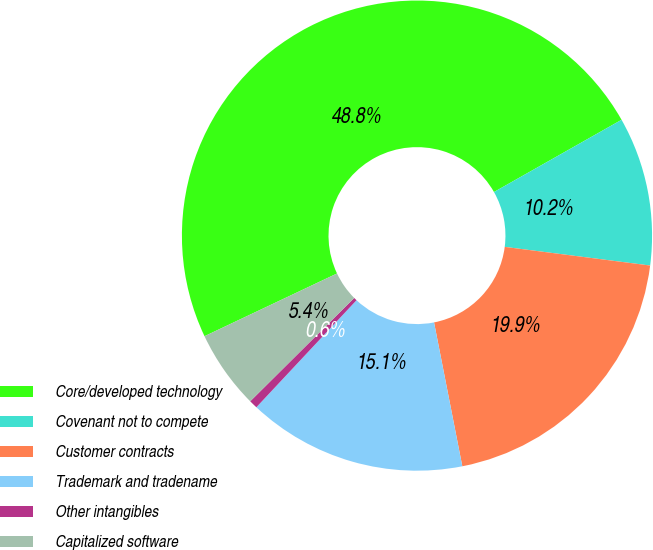<chart> <loc_0><loc_0><loc_500><loc_500><pie_chart><fcel>Core/developed technology<fcel>Covenant not to compete<fcel>Customer contracts<fcel>Trademark and tradename<fcel>Other intangibles<fcel>Capitalized software<nl><fcel>48.84%<fcel>10.23%<fcel>19.88%<fcel>15.06%<fcel>0.58%<fcel>5.41%<nl></chart> 